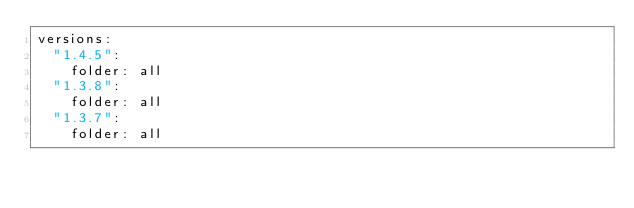<code> <loc_0><loc_0><loc_500><loc_500><_YAML_>versions:
  "1.4.5":
    folder: all
  "1.3.8":
    folder: all
  "1.3.7":
    folder: all
</code> 